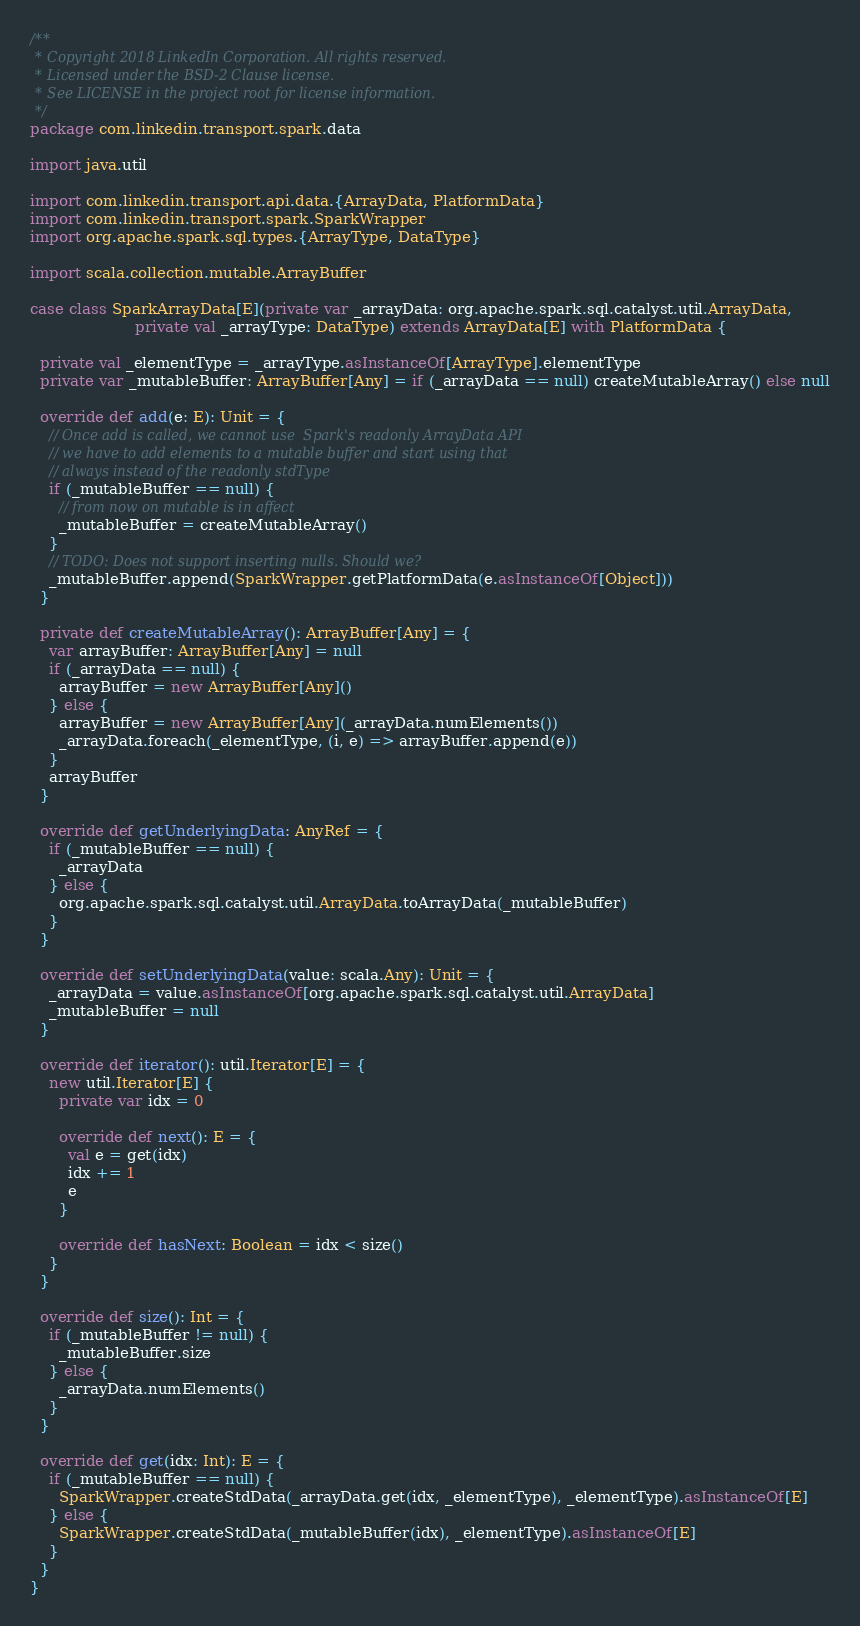<code> <loc_0><loc_0><loc_500><loc_500><_Scala_>/**
 * Copyright 2018 LinkedIn Corporation. All rights reserved.
 * Licensed under the BSD-2 Clause license.
 * See LICENSE in the project root for license information.
 */
package com.linkedin.transport.spark.data

import java.util

import com.linkedin.transport.api.data.{ArrayData, PlatformData}
import com.linkedin.transport.spark.SparkWrapper
import org.apache.spark.sql.types.{ArrayType, DataType}

import scala.collection.mutable.ArrayBuffer

case class SparkArrayData[E](private var _arrayData: org.apache.spark.sql.catalyst.util.ArrayData,
                      private val _arrayType: DataType) extends ArrayData[E] with PlatformData {

  private val _elementType = _arrayType.asInstanceOf[ArrayType].elementType
  private var _mutableBuffer: ArrayBuffer[Any] = if (_arrayData == null) createMutableArray() else null

  override def add(e: E): Unit = {
    // Once add is called, we cannot use  Spark's readonly ArrayData API
    // we have to add elements to a mutable buffer and start using that
    // always instead of the readonly stdType
    if (_mutableBuffer == null) {
      // from now on mutable is in affect
      _mutableBuffer = createMutableArray()
    }
    // TODO: Does not support inserting nulls. Should we?
    _mutableBuffer.append(SparkWrapper.getPlatformData(e.asInstanceOf[Object]))
  }

  private def createMutableArray(): ArrayBuffer[Any] = {
    var arrayBuffer: ArrayBuffer[Any] = null
    if (_arrayData == null) {
      arrayBuffer = new ArrayBuffer[Any]()
    } else {
      arrayBuffer = new ArrayBuffer[Any](_arrayData.numElements())
      _arrayData.foreach(_elementType, (i, e) => arrayBuffer.append(e))
    }
    arrayBuffer
  }

  override def getUnderlyingData: AnyRef = {
    if (_mutableBuffer == null) {
      _arrayData
    } else {
      org.apache.spark.sql.catalyst.util.ArrayData.toArrayData(_mutableBuffer)
    }
  }

  override def setUnderlyingData(value: scala.Any): Unit = {
    _arrayData = value.asInstanceOf[org.apache.spark.sql.catalyst.util.ArrayData]
    _mutableBuffer = null
  }

  override def iterator(): util.Iterator[E] = {
    new util.Iterator[E] {
      private var idx = 0

      override def next(): E = {
        val e = get(idx)
        idx += 1
        e
      }

      override def hasNext: Boolean = idx < size()
    }
  }

  override def size(): Int = {
    if (_mutableBuffer != null) {
      _mutableBuffer.size
    } else {
      _arrayData.numElements()
    }
  }

  override def get(idx: Int): E = {
    if (_mutableBuffer == null) {
      SparkWrapper.createStdData(_arrayData.get(idx, _elementType), _elementType).asInstanceOf[E]
    } else {
      SparkWrapper.createStdData(_mutableBuffer(idx), _elementType).asInstanceOf[E]
    }
  }
}
</code> 